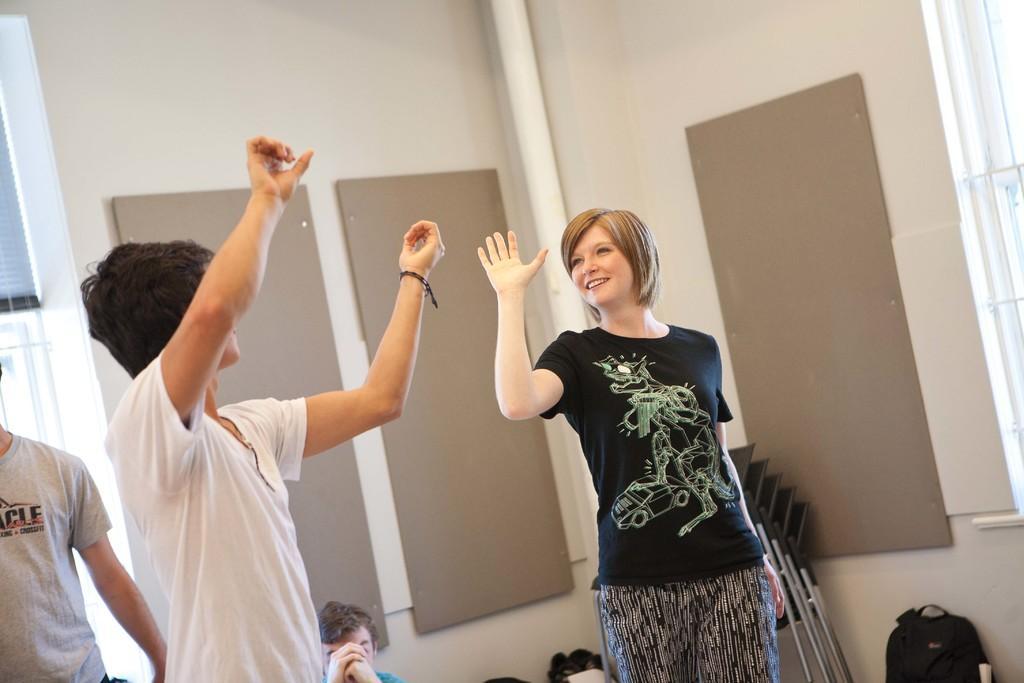In one or two sentences, can you explain what this image depicts? In the foreground of this picture, there is a man and a woman showing their hands up in the air. In the background, there are bags, chairs, wall, pipe, window blind and two men. 